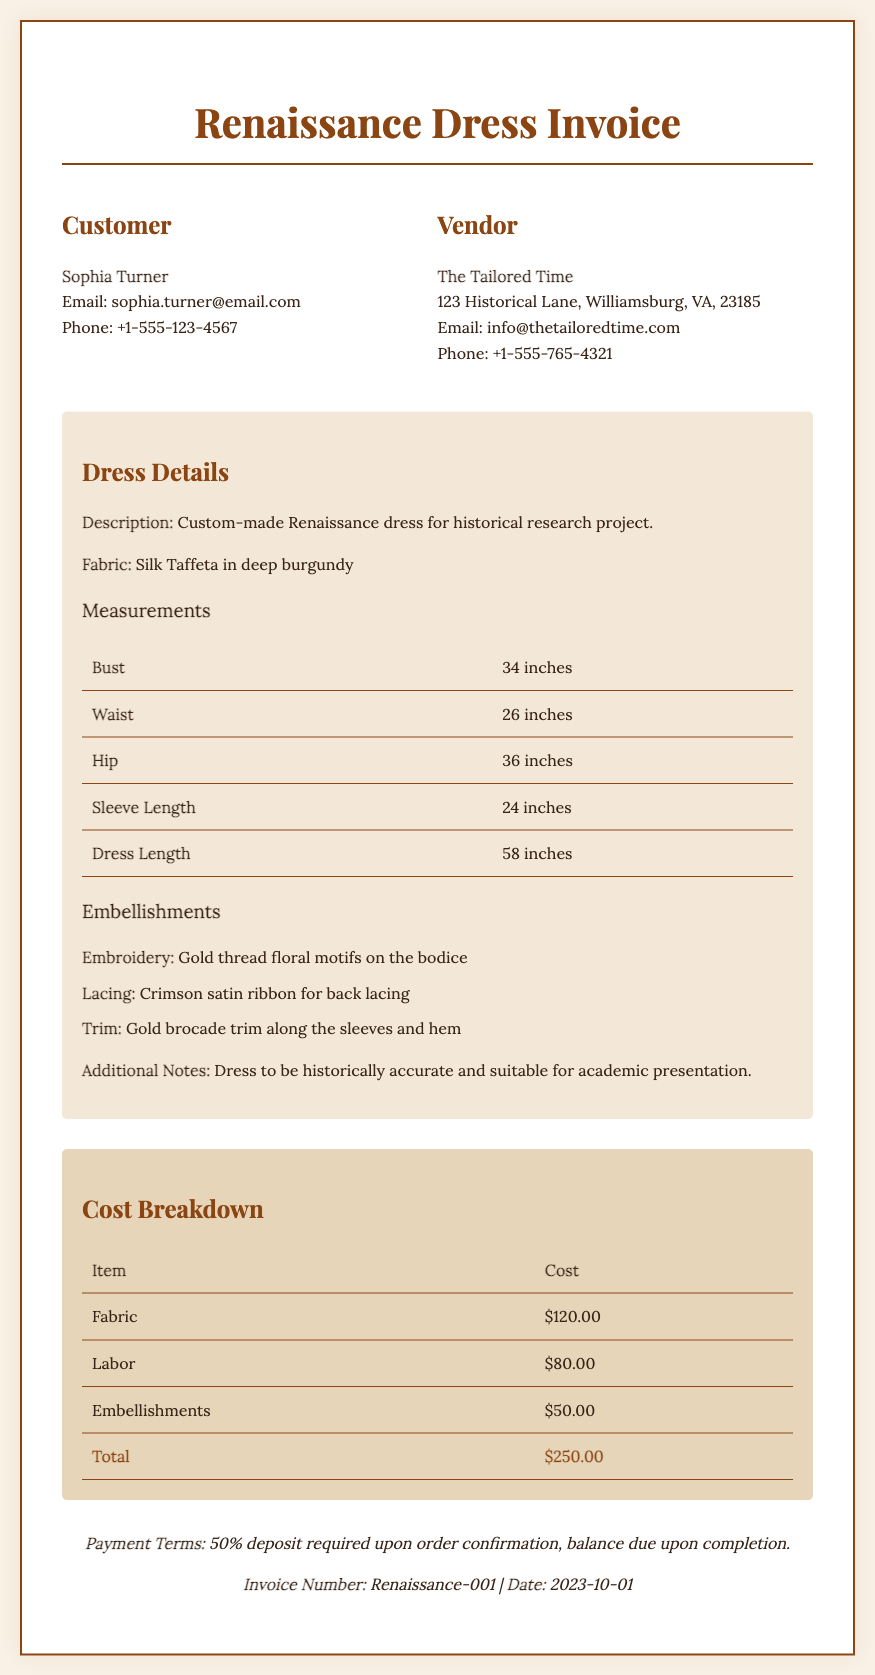What is the customer's name? The customer's name is stated in the header section of the document.
Answer: Sophia Turner What type of fabric is used for the dress? The fabric type is mentioned under the dress details section.
Answer: Silk Taffeta in deep burgundy What is the total cost for the dress? The total cost is listed in the cost breakdown table.
Answer: $250.00 How many inches is the dress length? The dress length measurement is provided in the measurements table.
Answer: 58 inches What embellishment is used for lacing? The lacing detail is listed under the embellishments section.
Answer: Crimson satin ribbon for back lacing What is the email address of the vendor? The vendor's email is provided in the header section.
Answer: info@thetailoredtime.com What payment term is mentioned regarding the balance? The payment terms provide details on the balance due after order completion.
Answer: Balance due upon completion When was the invoice created? The invoice date is stated in the footer section of the document.
Answer: 2023-10-01 What is the waist measurement? The waist measurement is included in the measurements table.
Answer: 26 inches 